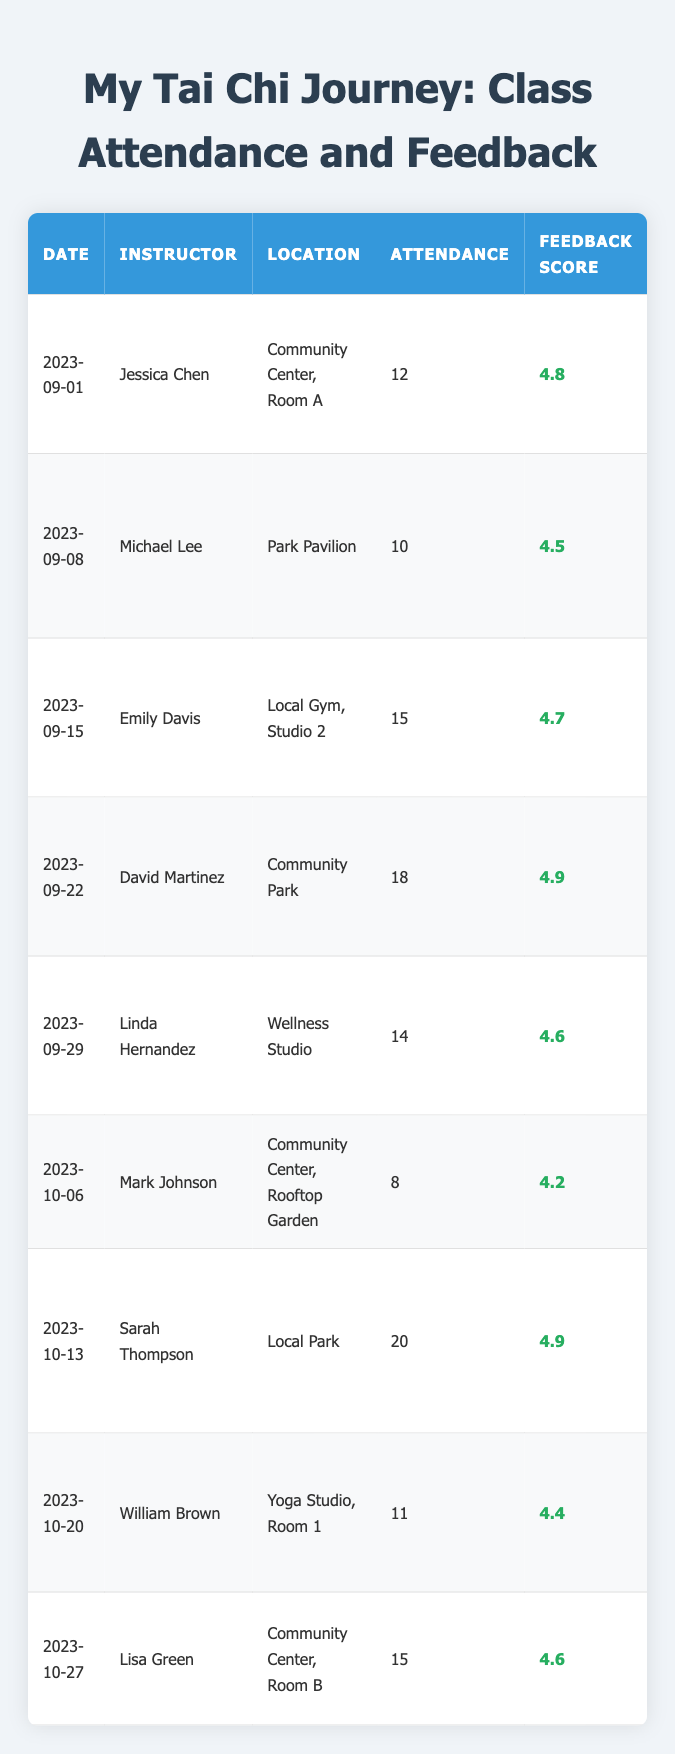What was the highest feedback score recorded? The table lists feedback scores for each class. Scanning the scores, the highest is 4.9 for the classes held on "2023-09-22" and "2023-10-13".
Answer: 4.9 How many classes had an attendance of 15 or more? By counting the rows where attendance is 15 or above, we have five classes: "2023-09-15", "2023-09-22", "2023-10-13", "2023-10-27", which have attendances of 15, 18, 20, and 15 respectively.
Answer: 5 What was the average attendance across all classes? To find the average, sum the attendance figures (12 + 10 + 15 + 18 + 14 + 8 + 20 + 11 + 15) = 133 and divide by the number of classes (9), which gives us 133 / 9 = 14.78.
Answer: 14.78 Did any class receive a feedback score lower than 4.3? Checking all the feedback scores, the lowest score is 4.2 from the class on "2023-10-06". Therefore, yes, there is a class with a score below 4.3.
Answer: Yes Which instructor had the most attendees in their class? Look through the attendance numbers: "2023-10-13" with Sarah Thompson has the highest attendance at 20.
Answer: Sarah Thompson What was the feedback score for the class that took place on "2023-10-20"? Directly referencing the table, the feedback score for that date is listed as 4.4.
Answer: 4.4 How many instructors had feedback scores of 4.5 or higher? Counting the entries with scores of 4.5 or above, there are eight instructors: Jessica Chen, Michael Lee, Emily Davis, David Martinez, Linda Hernandez, Sarah Thompson, William Brown, and Lisa Green.
Answer: 8 If we consider all sessions, what is the median feedback score? To find the median, we arrange the scores in order: [4.2, 4.4, 4.5, 4.6, 4.6, 4.7, 4.8, 4.9, 4.9]. The middle value (5th score) is 4.6 from this list.
Answer: 4.6 Did more than half of the classes have an attendance of 12 or more? There are 9 classes total, and counting those with 12 or more, we find 6 classes (12, 15, 18, 14, 20, 15), which is greater than half (4.5).
Answer: Yes Which location had the least attendance and what was it? The location with the least attendance is "Community Center, Rooftop Garden" with an attendance of 8 on "2023-10-06".
Answer: Community Center, Rooftop Garden; 8 